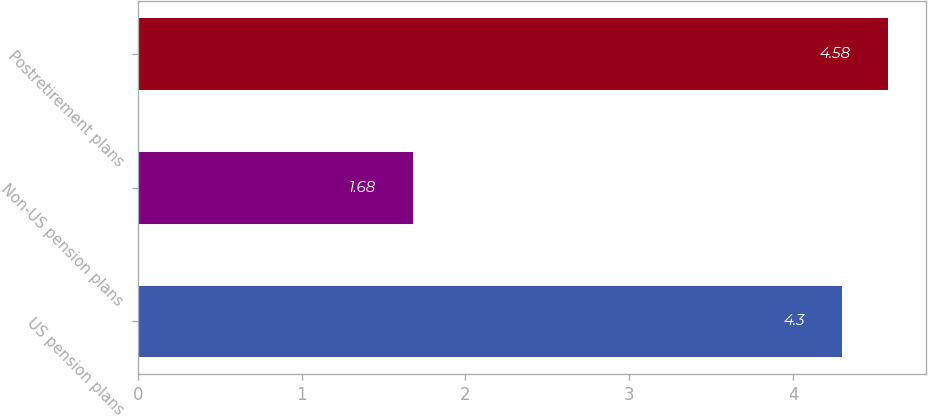Convert chart to OTSL. <chart><loc_0><loc_0><loc_500><loc_500><bar_chart><fcel>US pension plans<fcel>Non-US pension plans<fcel>Postretirement plans<nl><fcel>4.3<fcel>1.68<fcel>4.58<nl></chart> 